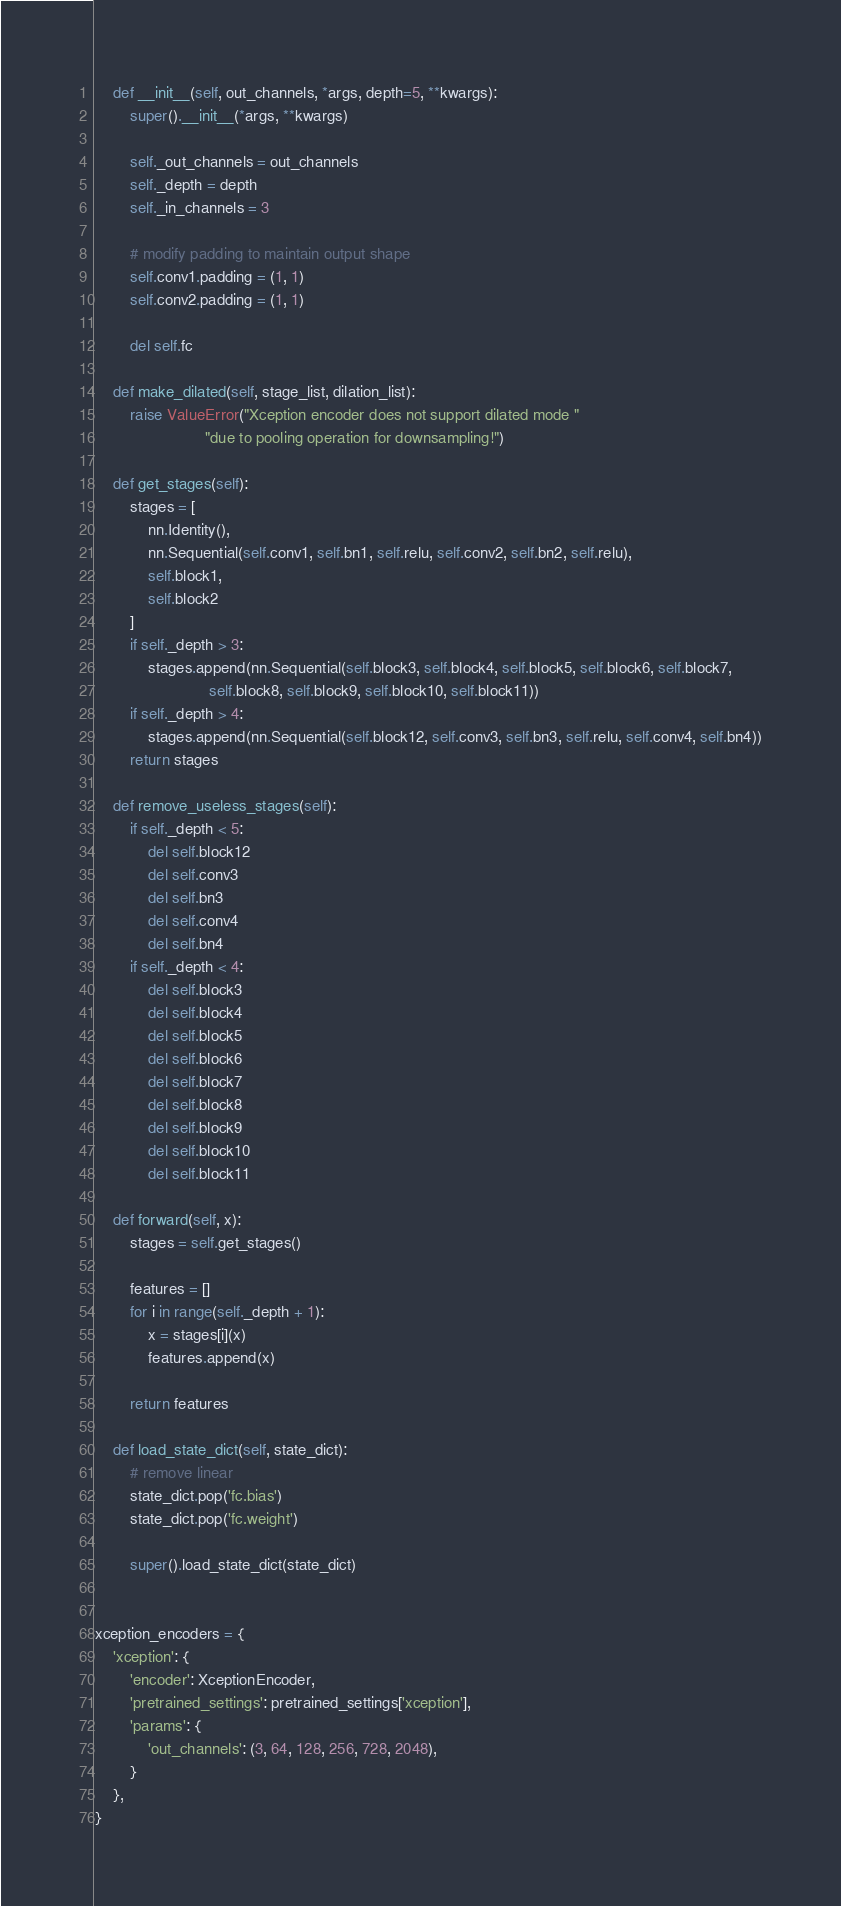Convert code to text. <code><loc_0><loc_0><loc_500><loc_500><_Python_>
    def __init__(self, out_channels, *args, depth=5, **kwargs):
        super().__init__(*args, **kwargs)

        self._out_channels = out_channels
        self._depth = depth
        self._in_channels = 3

        # modify padding to maintain output shape
        self.conv1.padding = (1, 1)
        self.conv2.padding = (1, 1)

        del self.fc

    def make_dilated(self, stage_list, dilation_list):
        raise ValueError("Xception encoder does not support dilated mode "
                         "due to pooling operation for downsampling!")

    def get_stages(self):
        stages = [
            nn.Identity(),
            nn.Sequential(self.conv1, self.bn1, self.relu, self.conv2, self.bn2, self.relu),
            self.block1,
            self.block2
        ]
        if self._depth > 3:
            stages.append(nn.Sequential(self.block3, self.block4, self.block5, self.block6, self.block7,
                          self.block8, self.block9, self.block10, self.block11))
        if self._depth > 4:
            stages.append(nn.Sequential(self.block12, self.conv3, self.bn3, self.relu, self.conv4, self.bn4))
        return stages

    def remove_useless_stages(self):
        if self._depth < 5:
            del self.block12
            del self.conv3
            del self.bn3
            del self.conv4
            del self.bn4
        if self._depth < 4:
            del self.block3
            del self.block4
            del self.block5
            del self.block6
            del self.block7
            del self.block8
            del self.block9
            del self.block10
            del self.block11

    def forward(self, x):
        stages = self.get_stages()

        features = []
        for i in range(self._depth + 1):
            x = stages[i](x)
            features.append(x)

        return features

    def load_state_dict(self, state_dict):
        # remove linear
        state_dict.pop('fc.bias')
        state_dict.pop('fc.weight')

        super().load_state_dict(state_dict)


xception_encoders = {
    'xception': {
        'encoder': XceptionEncoder,
        'pretrained_settings': pretrained_settings['xception'],
        'params': {
            'out_channels': (3, 64, 128, 256, 728, 2048),
        }
    },
}
</code> 